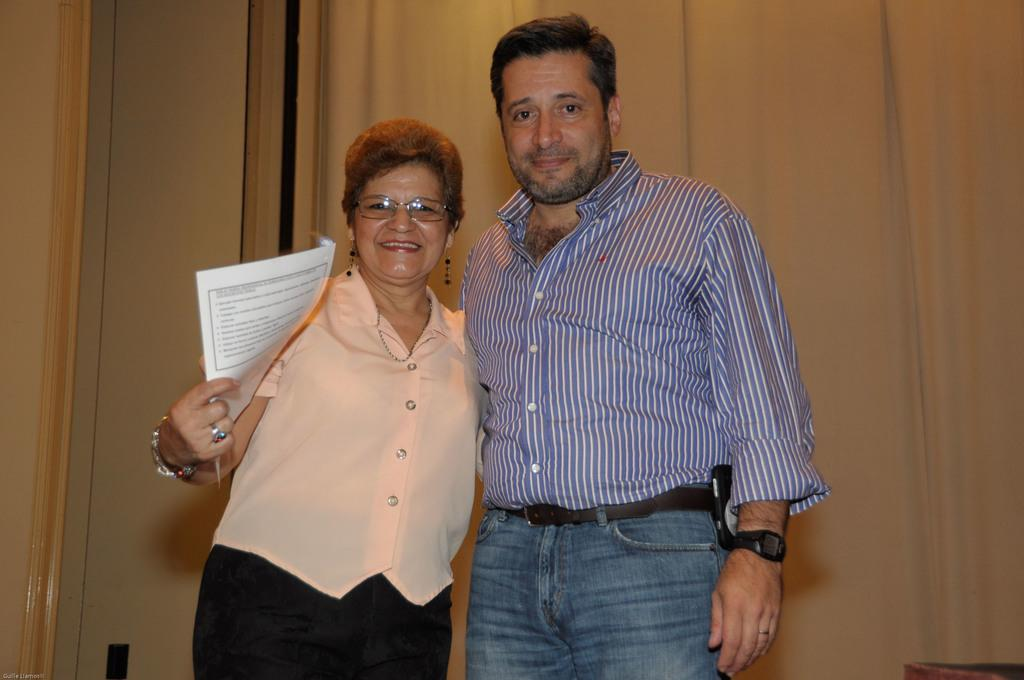How many people are present in the image? There are two people, a man and a woman, present in the image. What are the expressions of the people in the image? Both the man and woman are smiling in the image. What is the woman holding in the image? The woman is holding a paper in the image. What can be seen in the background of the image? There is a wall and a curtain in the background of the image. What type of skate is the man wearing in the image? There is no skate present in the image; both the man and woman are standing on a surface. How many pizzas can be seen on the table in the image? There is no table or pizzas present in the image. 